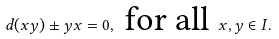<formula> <loc_0><loc_0><loc_500><loc_500>d ( x y ) \pm y x = 0 , \text {\ for all } x , y \in I .</formula> 